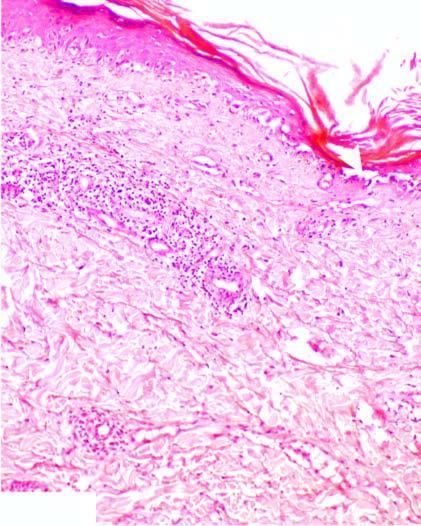what is there?
Answer the question using a single word or phrase. Hyperkeratosis and follicular plugging 